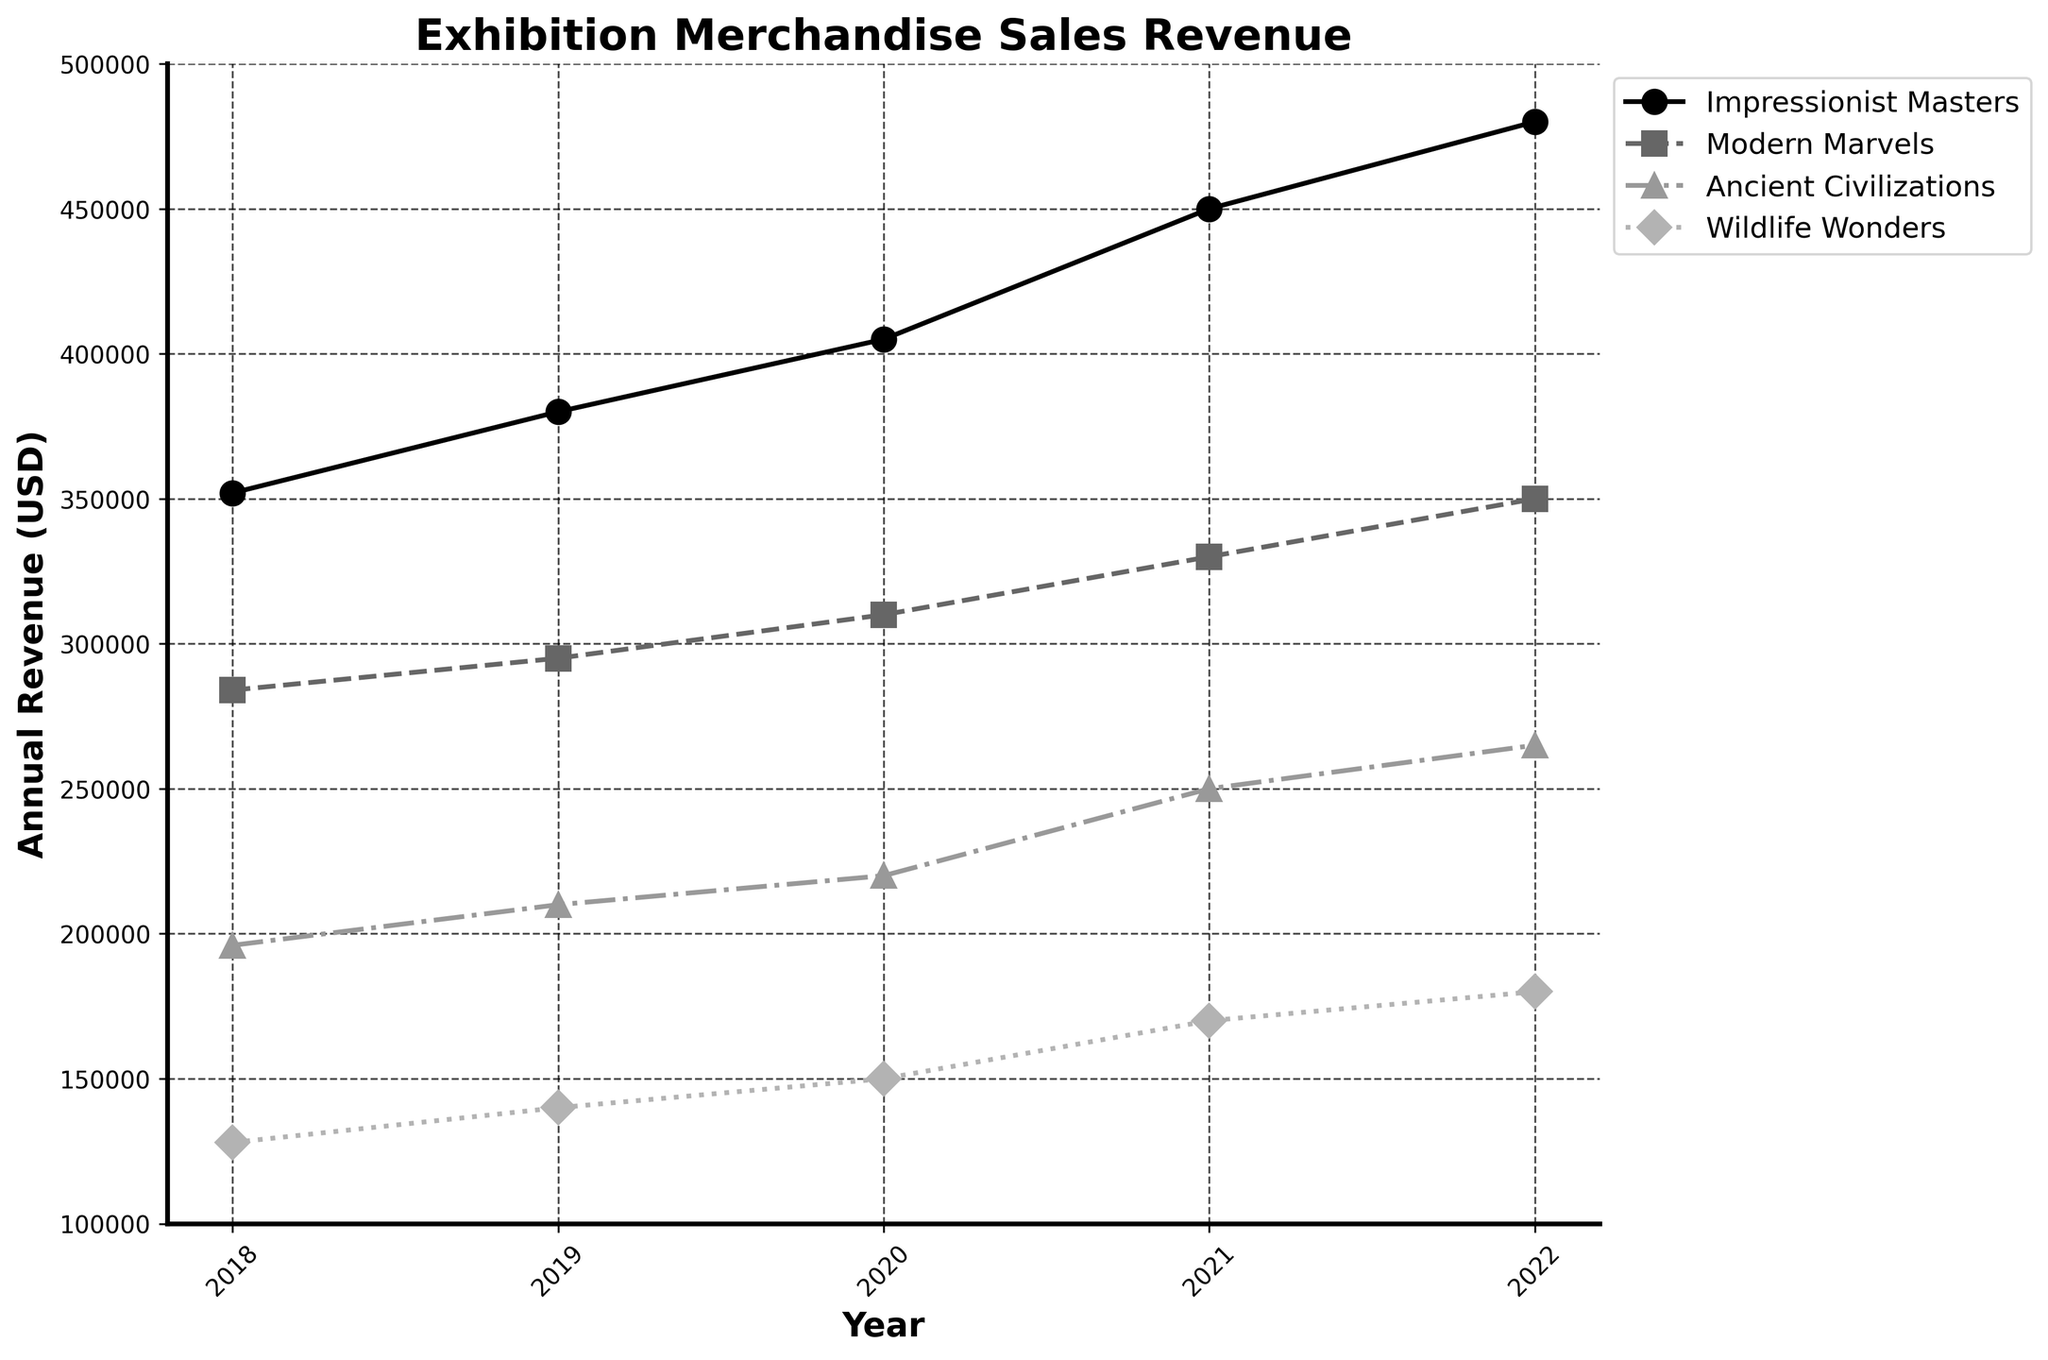What is the title of the plot? The title of the plot is clearly displayed at the top and reads "Exhibition Merchandise Sales Revenue".
Answer: Exhibition Merchandise Sales Revenue How many exhibition names are there in the plot? The plot displays four distinct exhibition names which can be identified by the labels in the legend.
Answer: Four Which exhibition had the highest annual revenue in 2022? By examining the data points for 2022, it is clear that "Impressionist Masters" had the highest annual revenue, as its data point is the highest on the y-axis.
Answer: Impressionist Masters What was the annual revenue for "Ancient Civilizations" in 2020? Locate the data point for "Ancient Civilizations" in the year 2020; it corresponds to the y-axis value displaying the annual revenue.
Answer: $220,000 How much did the revenue for "Wildlife Wonders" increase from 2018 to 2022? The revenue for "Wildlife Wonders" in 2018 was $128,000 and in 2022 it was $180,000. The difference is $180,000 - $128,000.
Answer: $52,000 Which exhibition showed the most consistent increase in revenue year over year? By analyzing the slopes of the lines for each exhibition, "Impressionist Masters" shows the most consistent increase since the line progresses steadily upward each year.
Answer: Impressionist Masters What is the revenue difference between "Modern Marvels" and "Wildlife Wonders" in 2021? The revenue for "Modern Marvels" in 2021 is $330,000, and the revenue for "Wildlife Wonders" in the same year is $170,000. The difference is $330,000 - $170,000.
Answer: $160,000 Did any exhibition see a decrease in revenue in any year between 2018 and 2022? By examining the plot lines for each exhibition, none exhibit a downward trend year over year. All lines either stay the same or increase.
Answer: No What year did "Impressionist Masters" surpass $400,000 in revenue? The data point for "Impressionist Masters" reaches above $400,000 starting in the year 2020.
Answer: 2020 Which exhibition experienced the largest revenue growth from 2018 to 2022? Calculate the revenue growth for each exhibition from 2018 to 2022: "Impressionist Masters" ($480,000 - $352,000 = $128,000), "Modern Marvels" ($350,000 - $284,000 = $66,000), "Ancient Civilizations" ($265,000 - $196,000 = $69,000), and "Wildlife Wonders" ($180,000 - $128,000 = $52,000). "Impressionist Masters" has the largest growth.
Answer: Impressionist Masters 